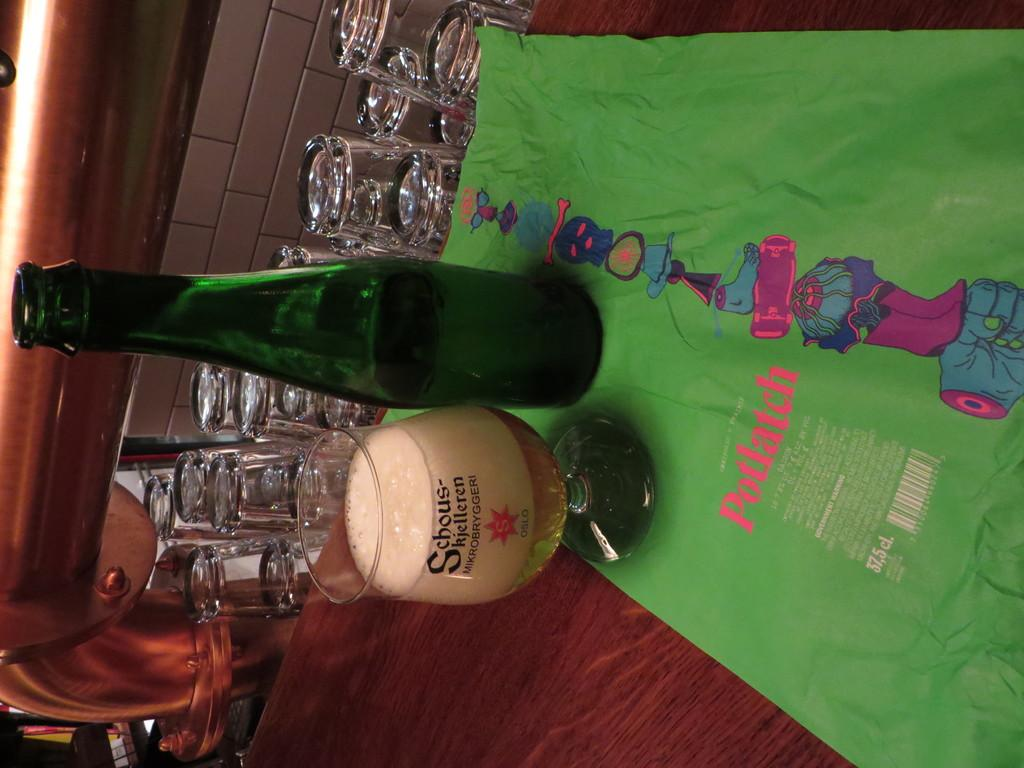<image>
Share a concise interpretation of the image provided. A green bottle and a glass of beer are on a green colored potlatch cloth. 